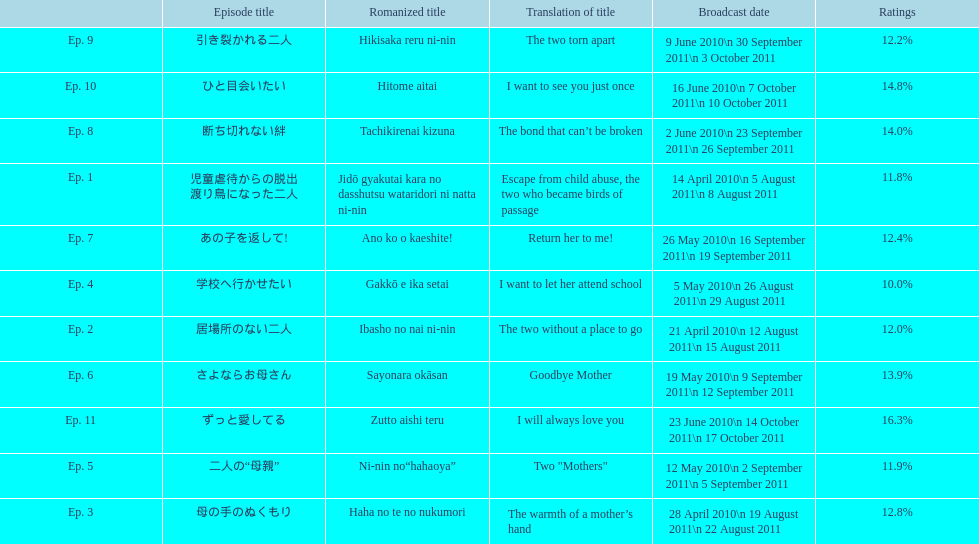How many continuous episodes received a rating of more than 11%? 7. 